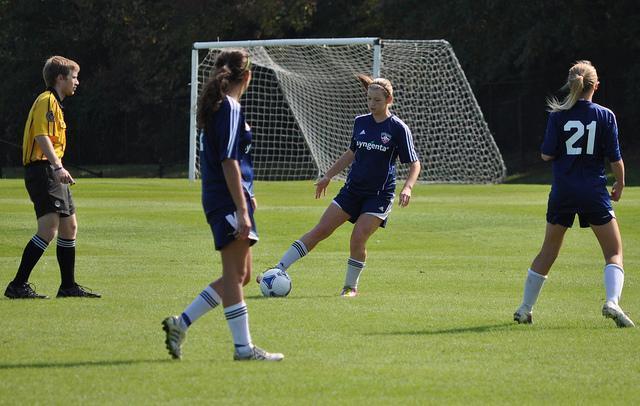Who will try to get the ball from the person who touches it?
Indicate the correct response and explain using: 'Answer: answer
Rationale: rationale.'
Options: Yellow person, 21, coach, referee. Answer: yellow person.
Rationale: There are two teams and the people in blue are playing against yellow. the person is blue has the ball. 